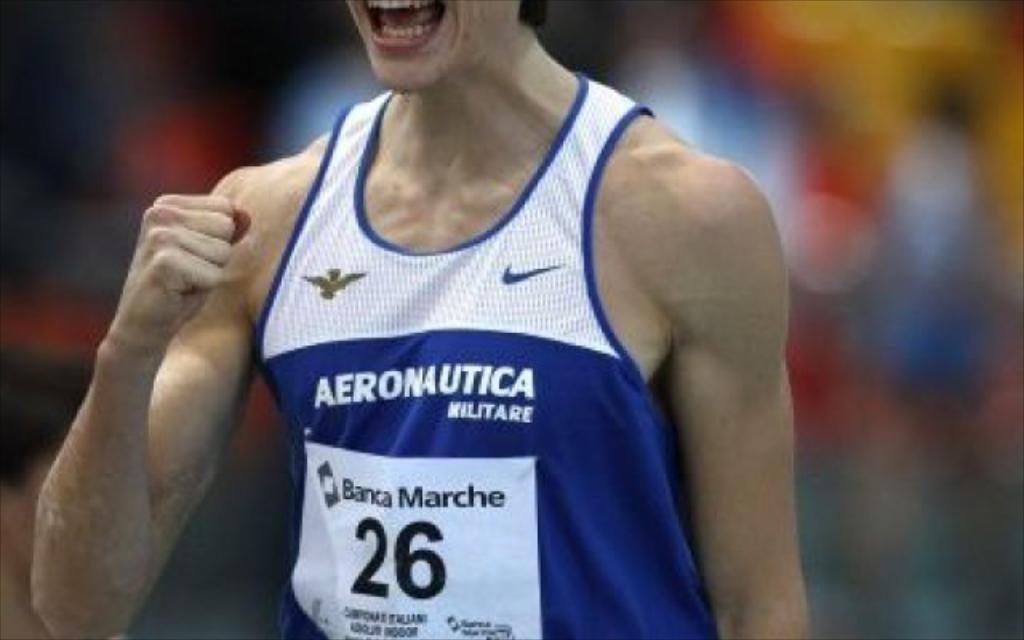<image>
Describe the image concisely. A person wearing an Aeronautica Militare tank top is making a fist. 